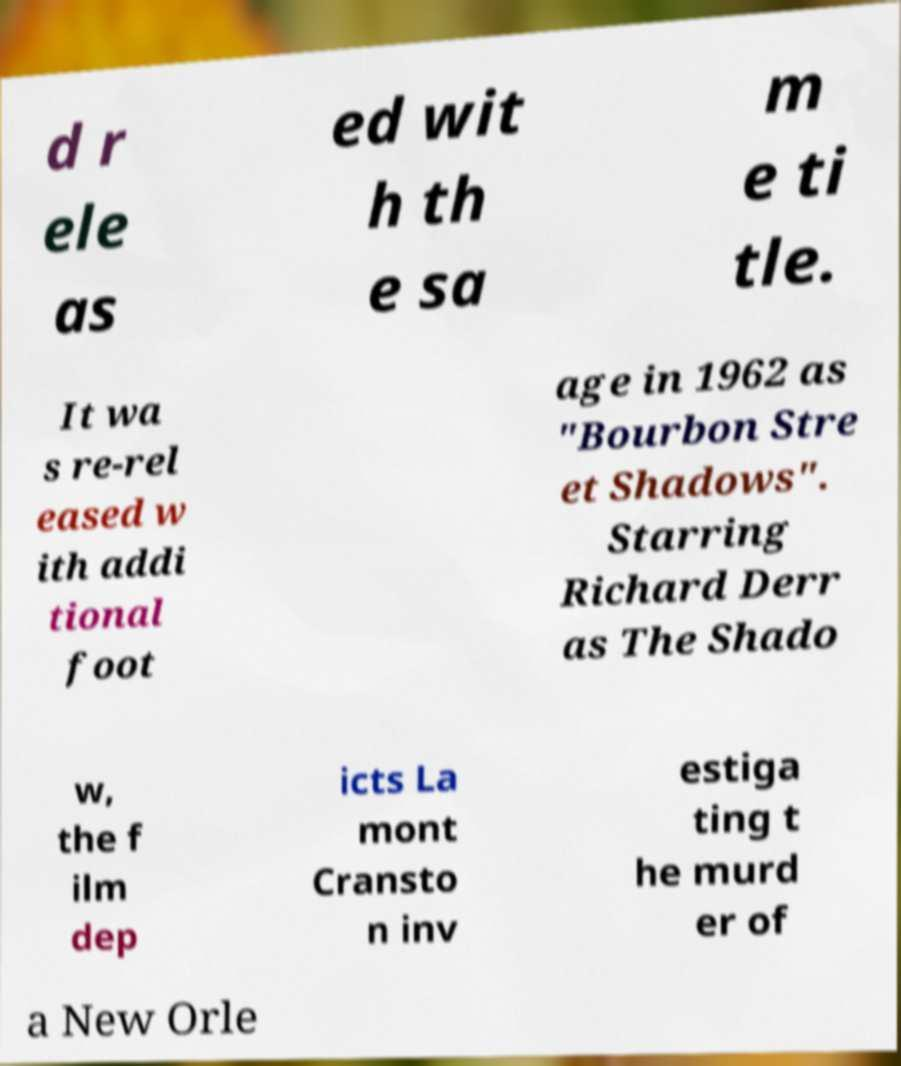Please identify and transcribe the text found in this image. d r ele as ed wit h th e sa m e ti tle. It wa s re-rel eased w ith addi tional foot age in 1962 as "Bourbon Stre et Shadows". Starring Richard Derr as The Shado w, the f ilm dep icts La mont Cransto n inv estiga ting t he murd er of a New Orle 